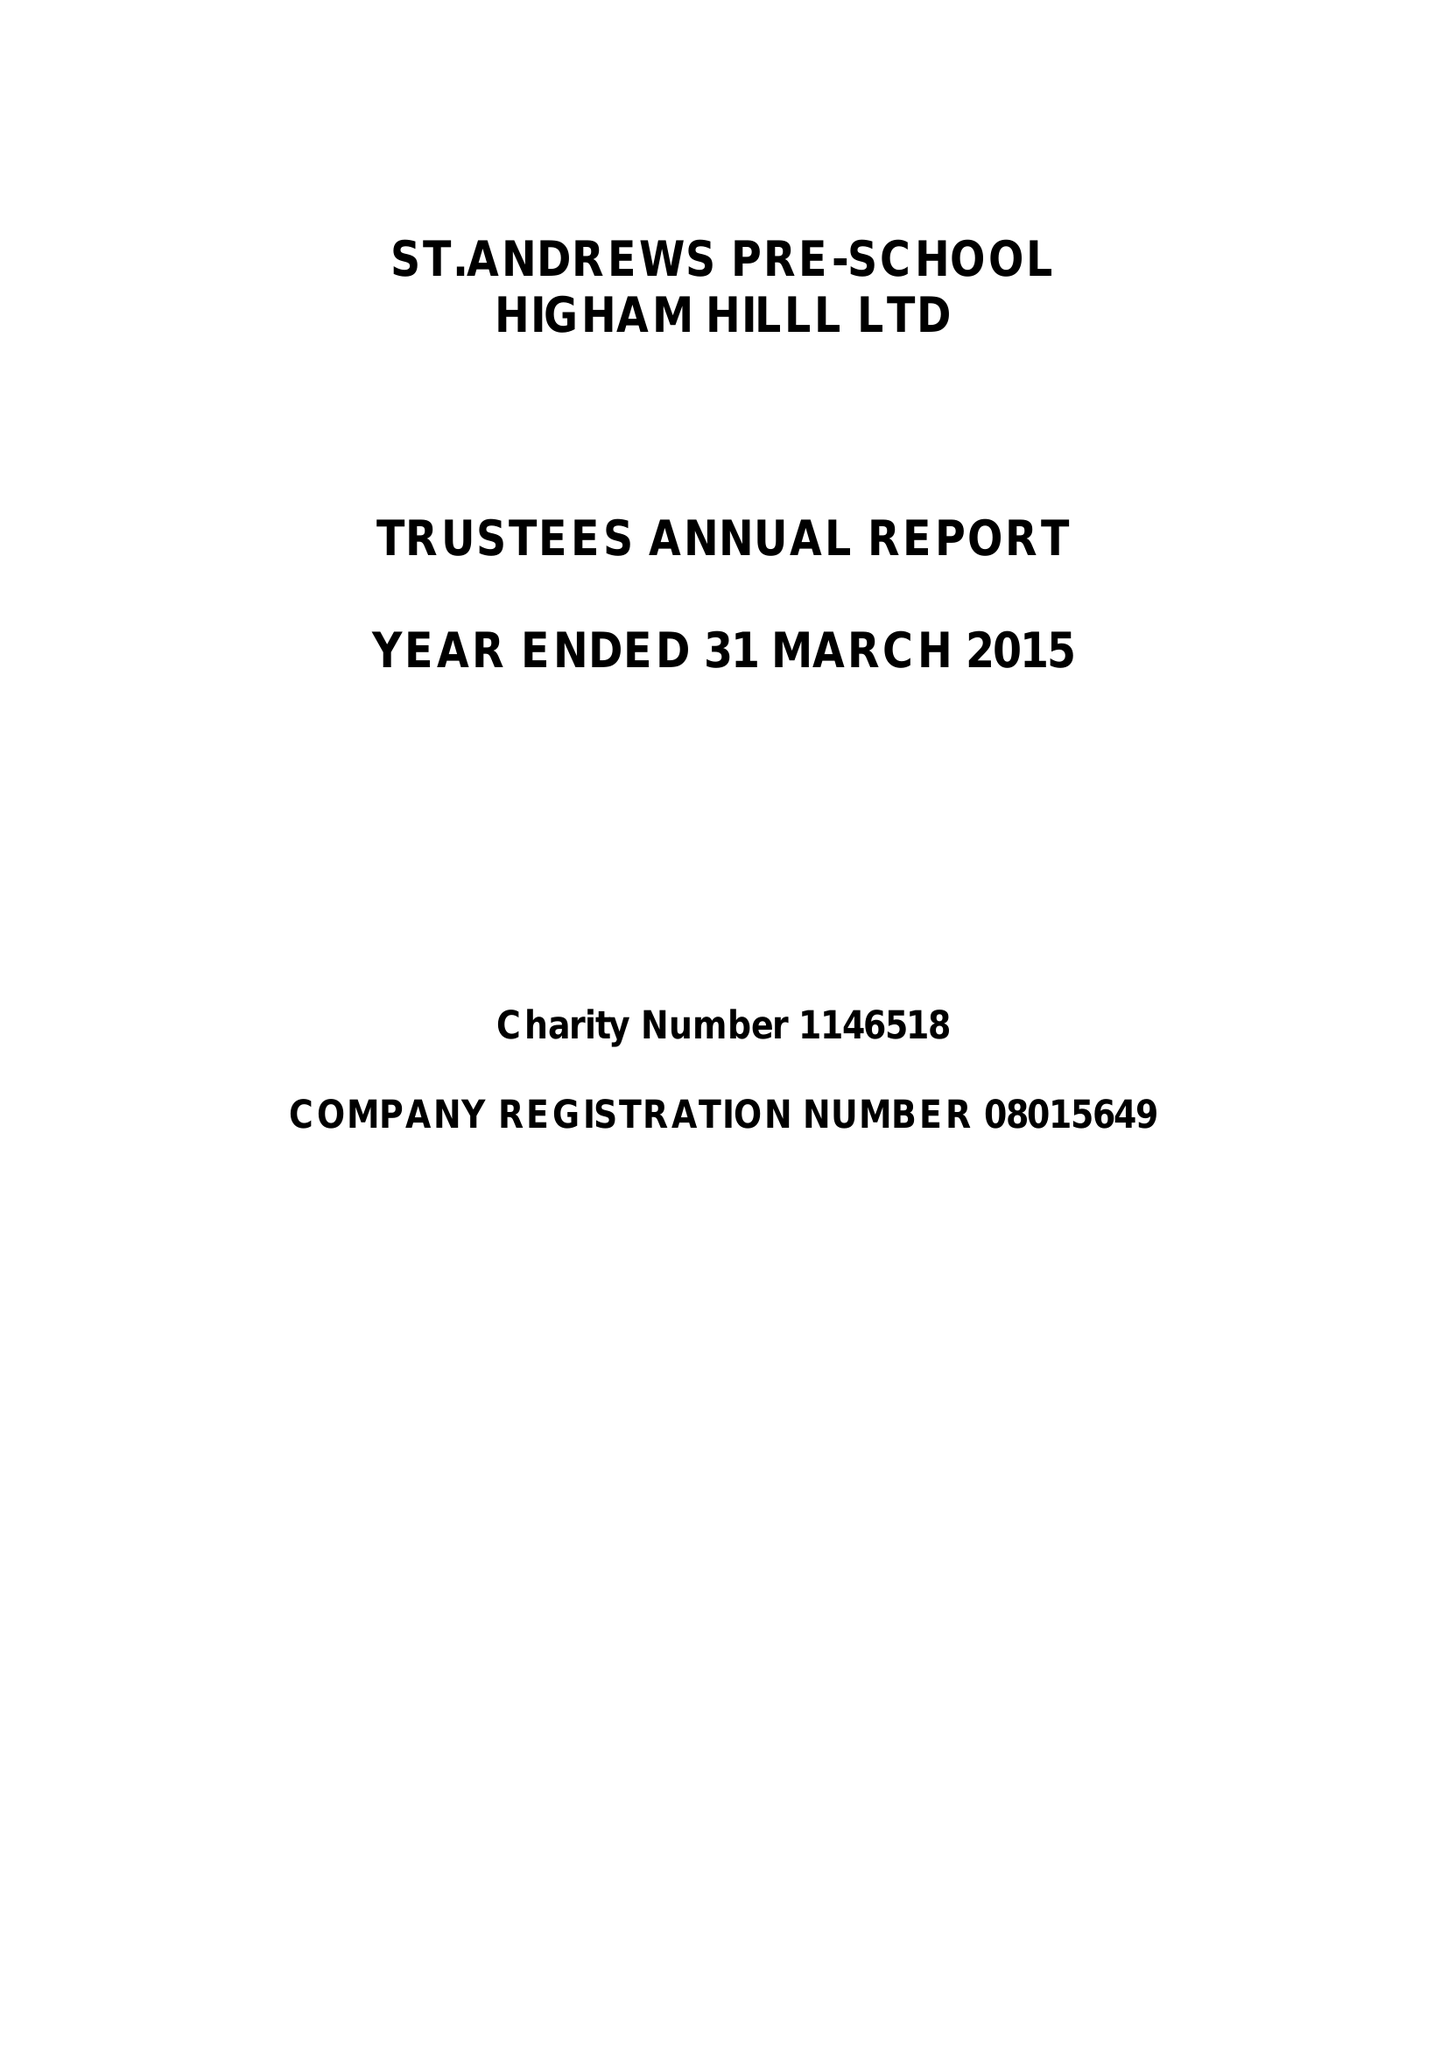What is the value for the charity_number?
Answer the question using a single word or phrase. 1146518 